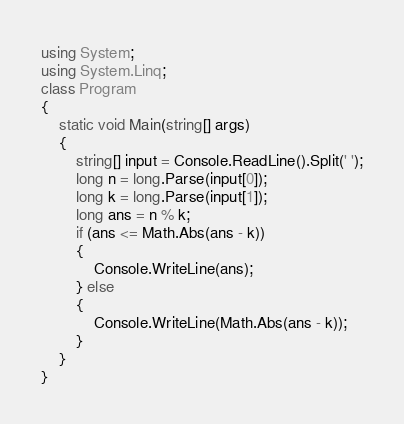<code> <loc_0><loc_0><loc_500><loc_500><_C#_>using System;
using System.Linq;
class Program
{
    static void Main(string[] args)
    {
        string[] input = Console.ReadLine().Split(' ');
        long n = long.Parse(input[0]);
        long k = long.Parse(input[1]);
        long ans = n % k;
        if (ans <= Math.Abs(ans - k))
        {
            Console.WriteLine(ans);
        } else
        {
            Console.WriteLine(Math.Abs(ans - k));
        }
    }
}</code> 